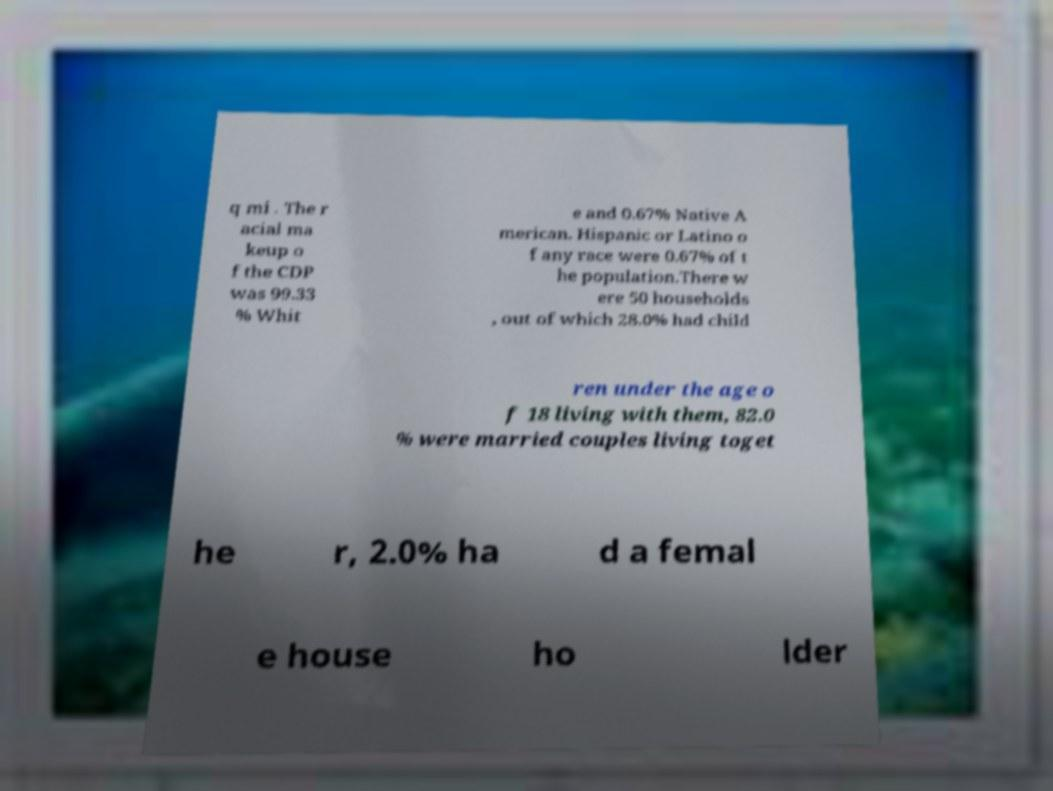What messages or text are displayed in this image? I need them in a readable, typed format. q mi . The r acial ma keup o f the CDP was 99.33 % Whit e and 0.67% Native A merican. Hispanic or Latino o f any race were 0.67% of t he population.There w ere 50 households , out of which 28.0% had child ren under the age o f 18 living with them, 82.0 % were married couples living toget he r, 2.0% ha d a femal e house ho lder 